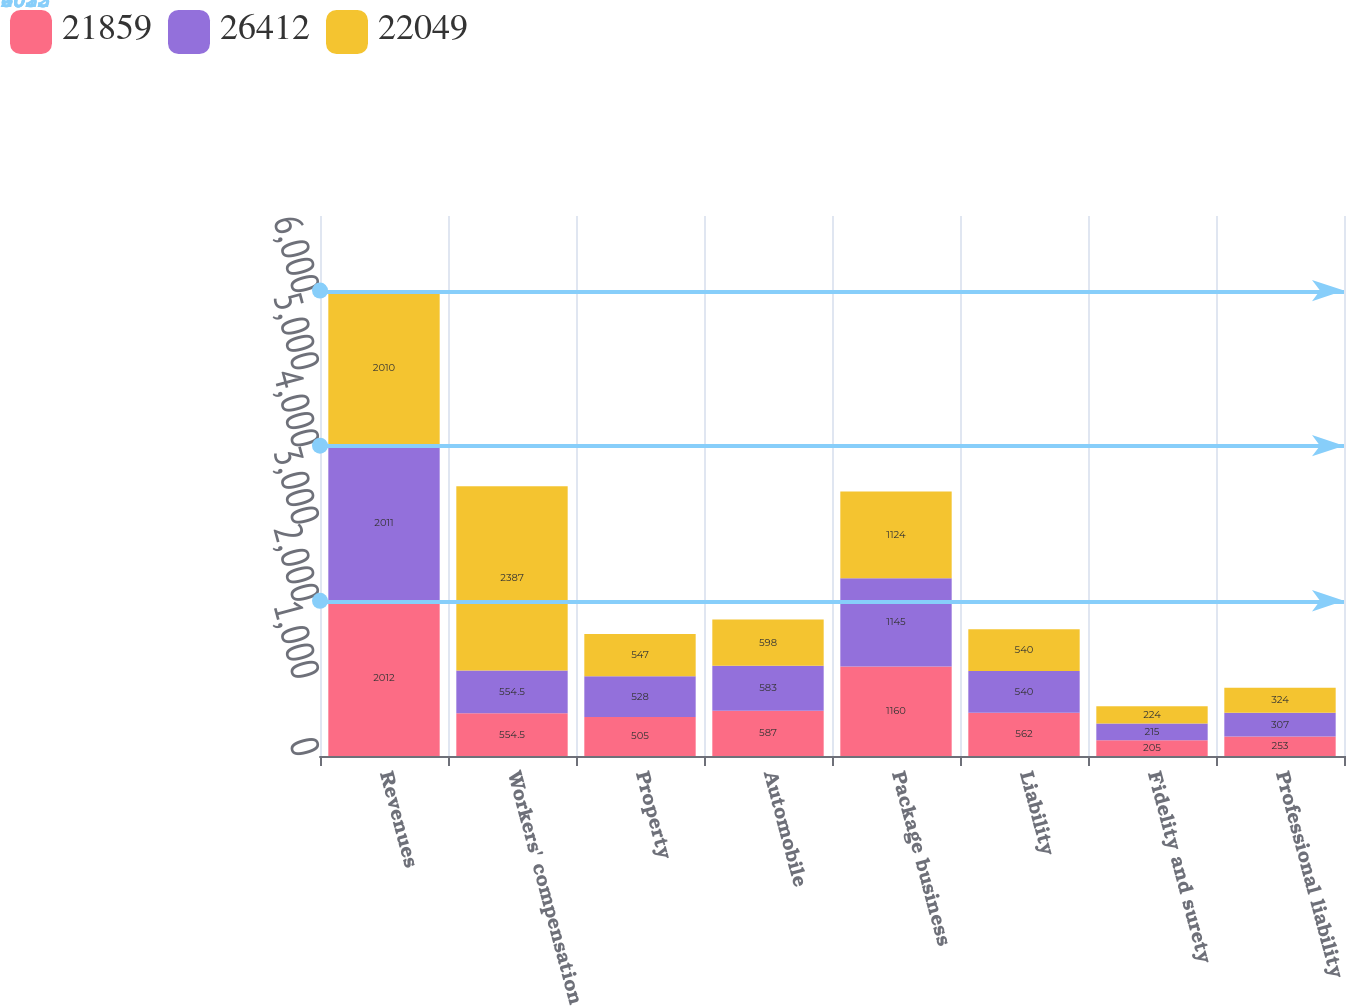<chart> <loc_0><loc_0><loc_500><loc_500><stacked_bar_chart><ecel><fcel>Revenues<fcel>Workers' compensation<fcel>Property<fcel>Automobile<fcel>Package business<fcel>Liability<fcel>Fidelity and surety<fcel>Professional liability<nl><fcel>21859<fcel>2012<fcel>554.5<fcel>505<fcel>587<fcel>1160<fcel>562<fcel>205<fcel>253<nl><fcel>26412<fcel>2011<fcel>554.5<fcel>528<fcel>583<fcel>1145<fcel>540<fcel>215<fcel>307<nl><fcel>22049<fcel>2010<fcel>2387<fcel>547<fcel>598<fcel>1124<fcel>540<fcel>224<fcel>324<nl></chart> 